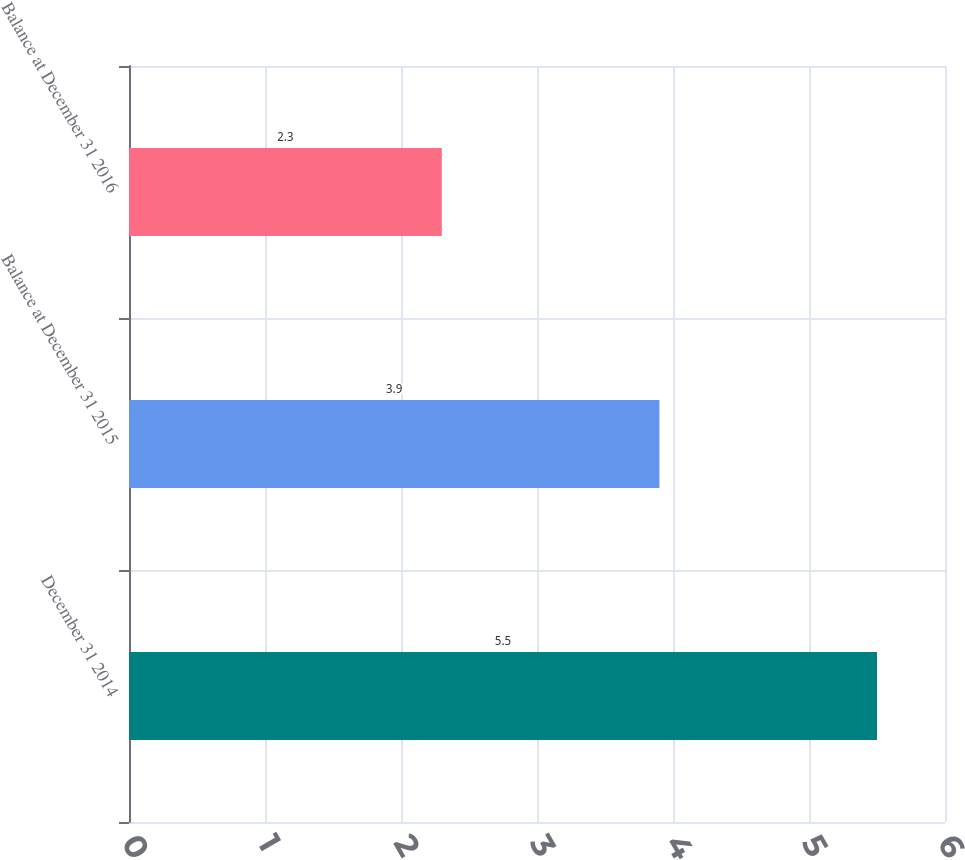Convert chart. <chart><loc_0><loc_0><loc_500><loc_500><bar_chart><fcel>December 31 2014<fcel>Balance at December 31 2015<fcel>Balance at December 31 2016<nl><fcel>5.5<fcel>3.9<fcel>2.3<nl></chart> 